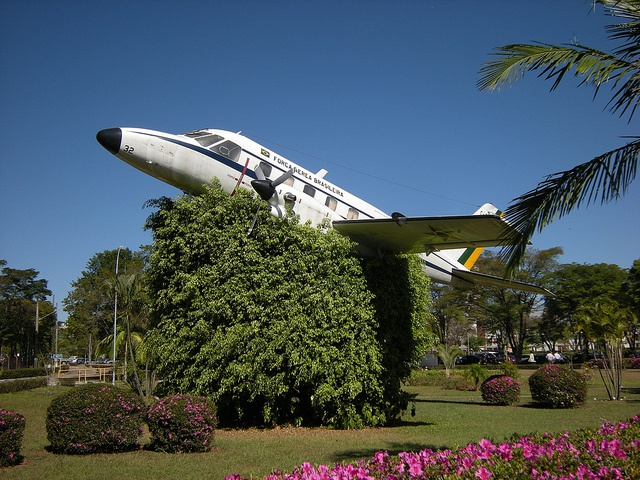Describe the objects in this image and their specific colors. I can see a airplane in navy, black, white, gray, and darkgray tones in this image. 